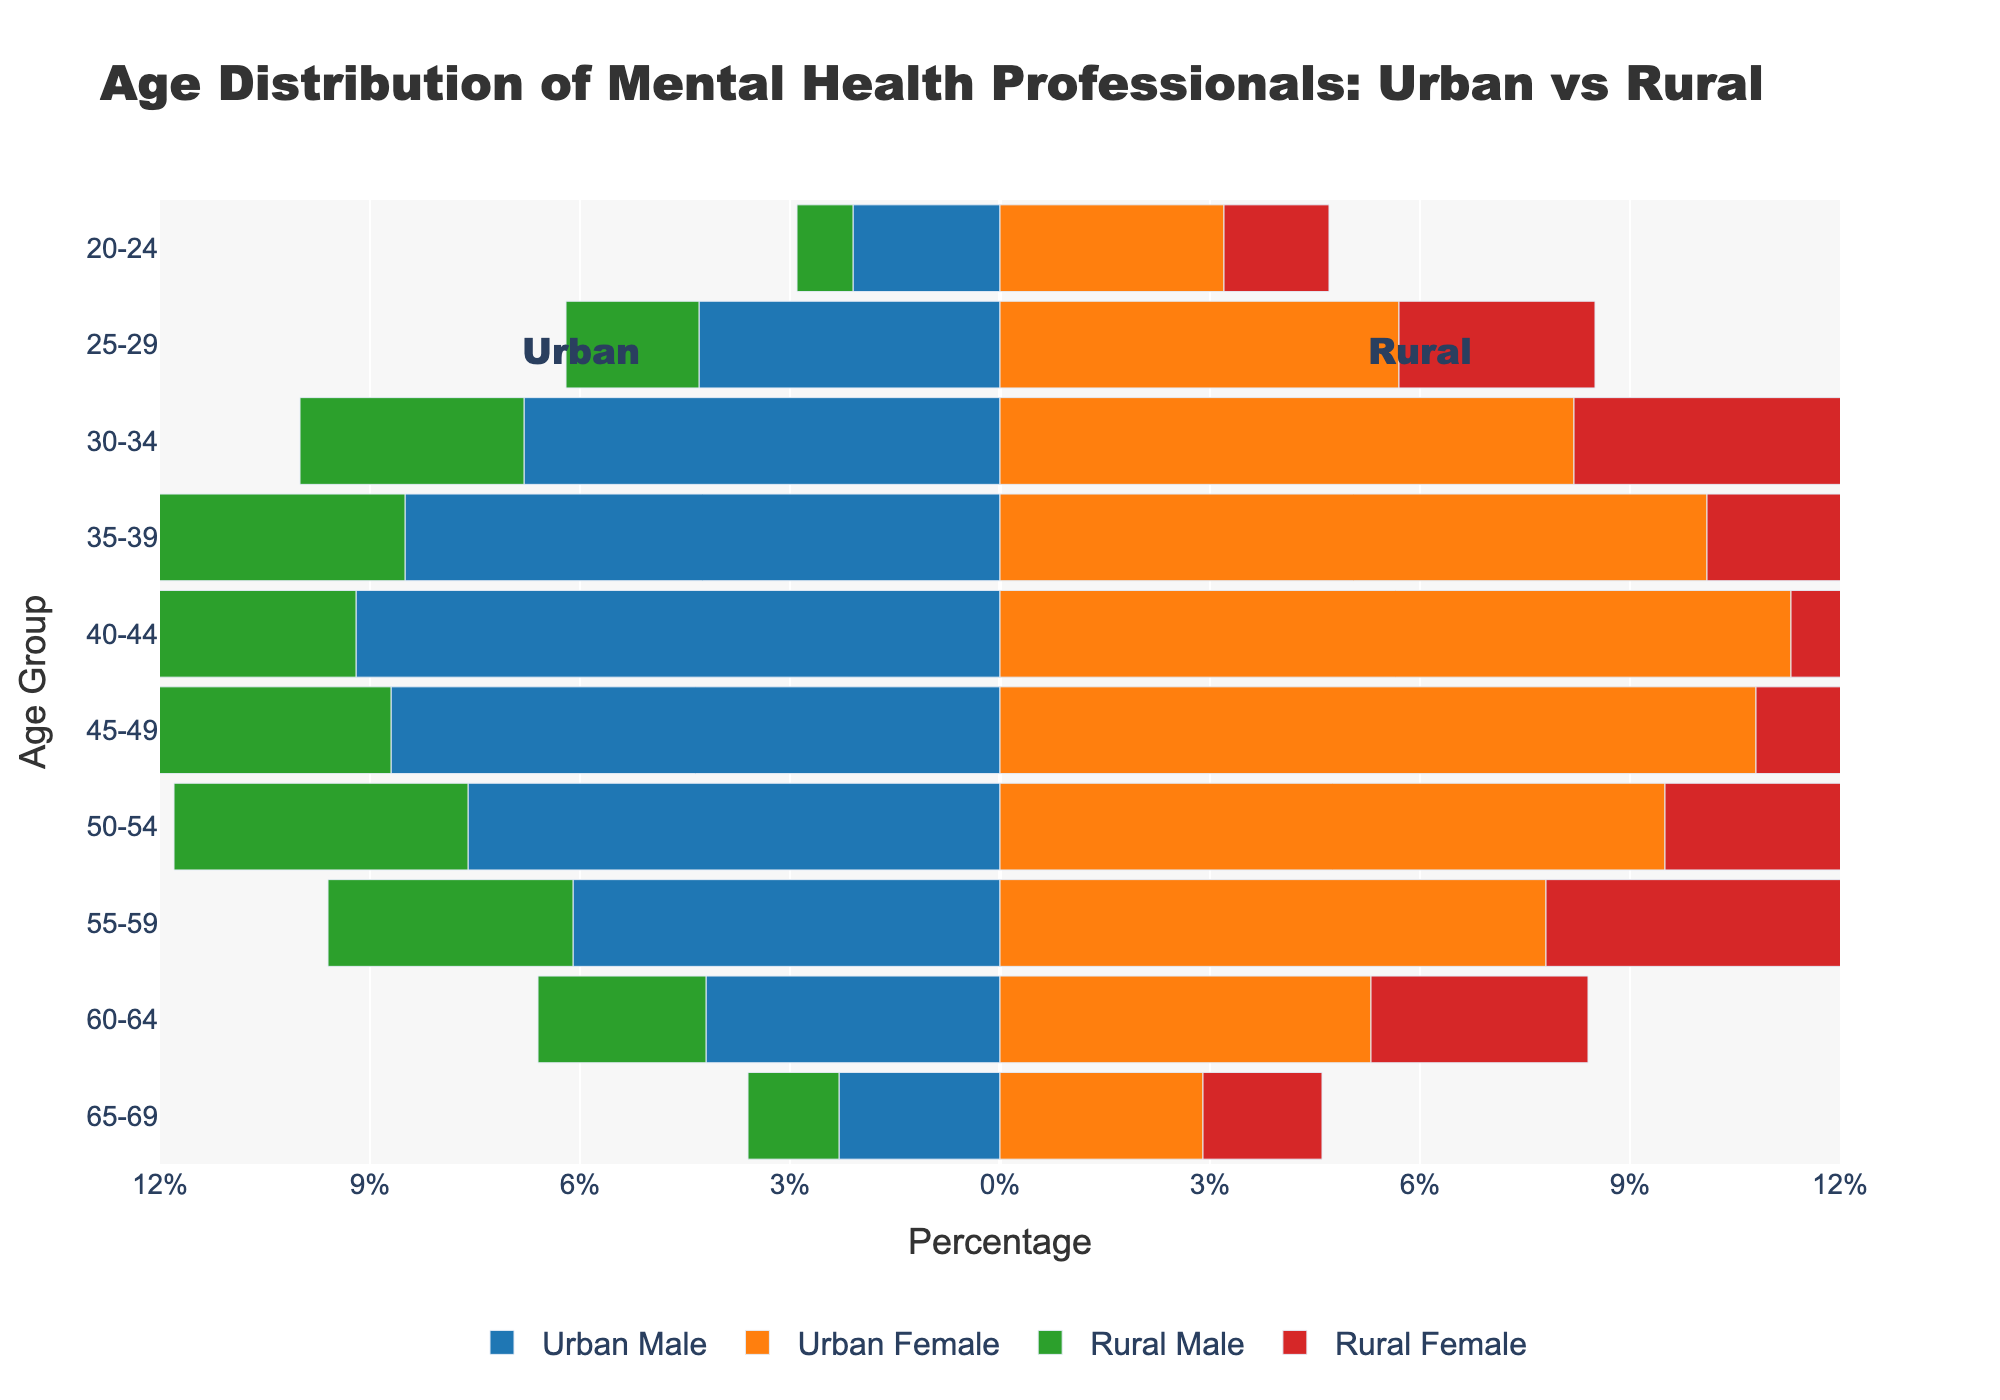What is the title of the figure? The title of the figure is displayed at the top of the chart.
Answer: Age Distribution of Mental Health Professionals: Urban vs Rural Which age group has the highest percentage of urban female mental health professionals? Look for the bar that extends the farthest to the right for the urban female category.
Answer: 40-44 In the 30-34 age group, which gender has a higher percentage in rural areas? Compare the lengths of the rural male and rural female bars for the 30-34 age group.
Answer: Rural Female How does the percentage of urban male professionals in the 25-29 age group compare to those in the 60-64 age group? Compare the negative bar lengths for urban males in the 25-29 and 60-64 age groups.
Answer: 25-29 has a higher percentage What is the overall trend in the percentages of urban female mental health professionals as the age increases? Observe the urban female bars from the youngest to the oldest age groups to identify a pattern.
Answer: Decreases with age Which age group has the smallest difference in percentage between rural male and rural female professionals? Calculate the absolute difference between rural male and female percentages for each age group and identify the smallest difference.
Answer: 65-69 Compare the percentage of urban females in the 40-44 age group to rural females in the same age group. Which is higher? Compare the lengths of the urban female and rural female bars for the 40-44 age group.
Answer: Urban Female In which age group is the difference between urban male and urban female professionals the largest? Compute the absolute difference between urban male and female percentages for each age group and find the largest difference.
Answer: 40-44 What is the total percentage of professionals aged 55-59 in rural areas (both genders combined)? Add the percentages of rural males and rural females in the 55-59 age group.
Answer: 7.8% Which has a higher percentage: urban male professionals aged 50-54 or rural male professionals aged 50-54? Compare the bar lengths for urban and rural males in the 50-54 age group.
Answer: Urban Male 